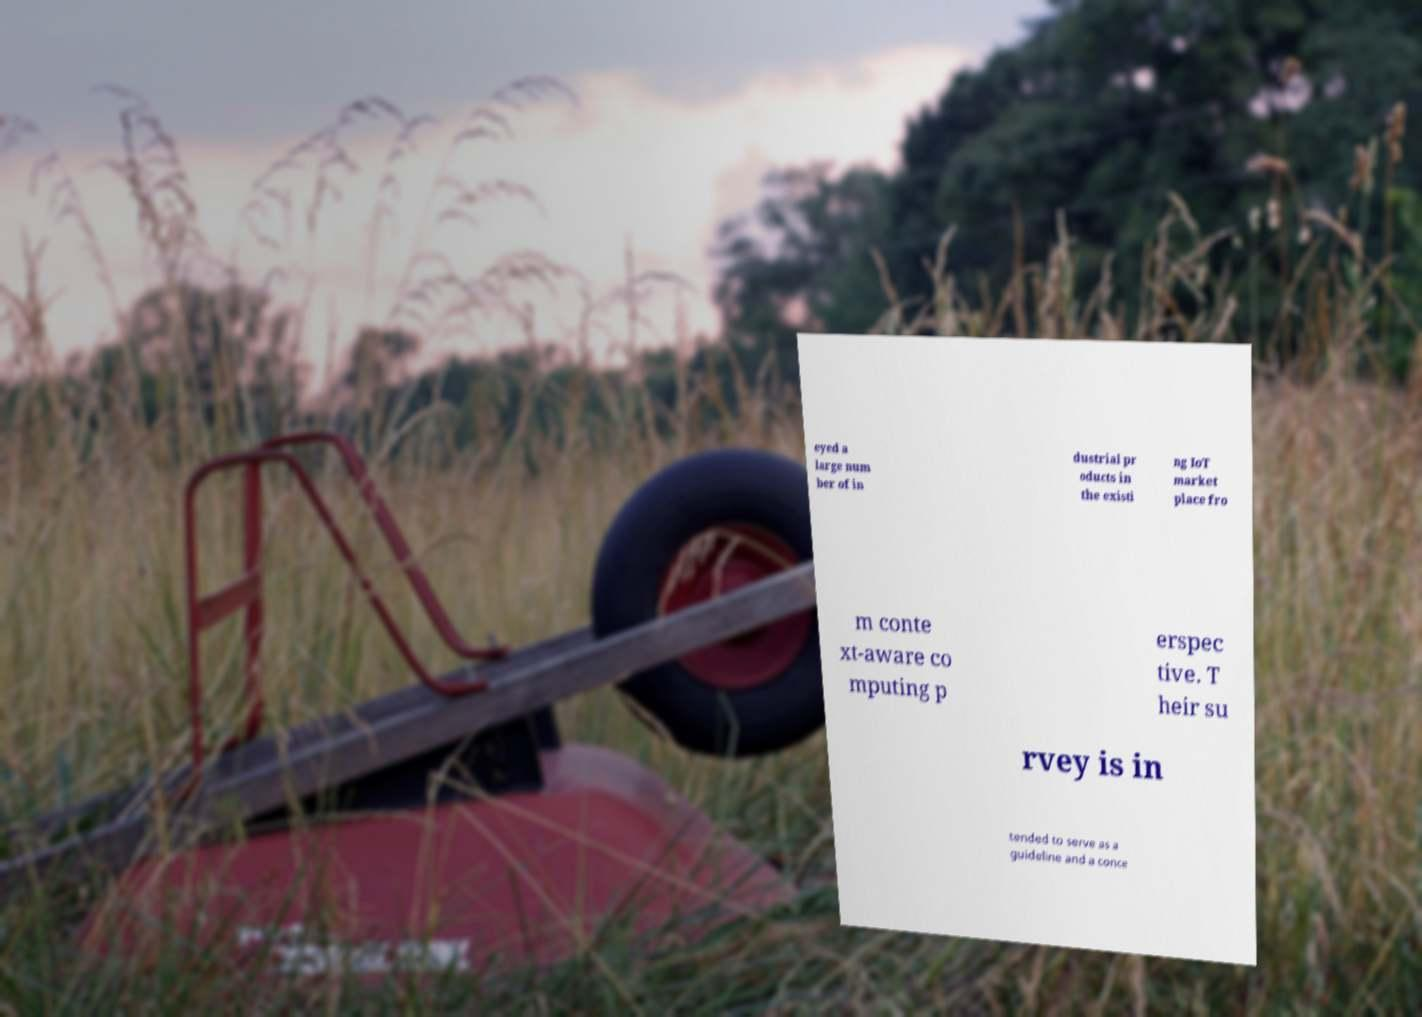For documentation purposes, I need the text within this image transcribed. Could you provide that? eyed a large num ber of in dustrial pr oducts in the existi ng IoT market place fro m conte xt-aware co mputing p erspec tive. T heir su rvey is in tended to serve as a guideline and a conce 